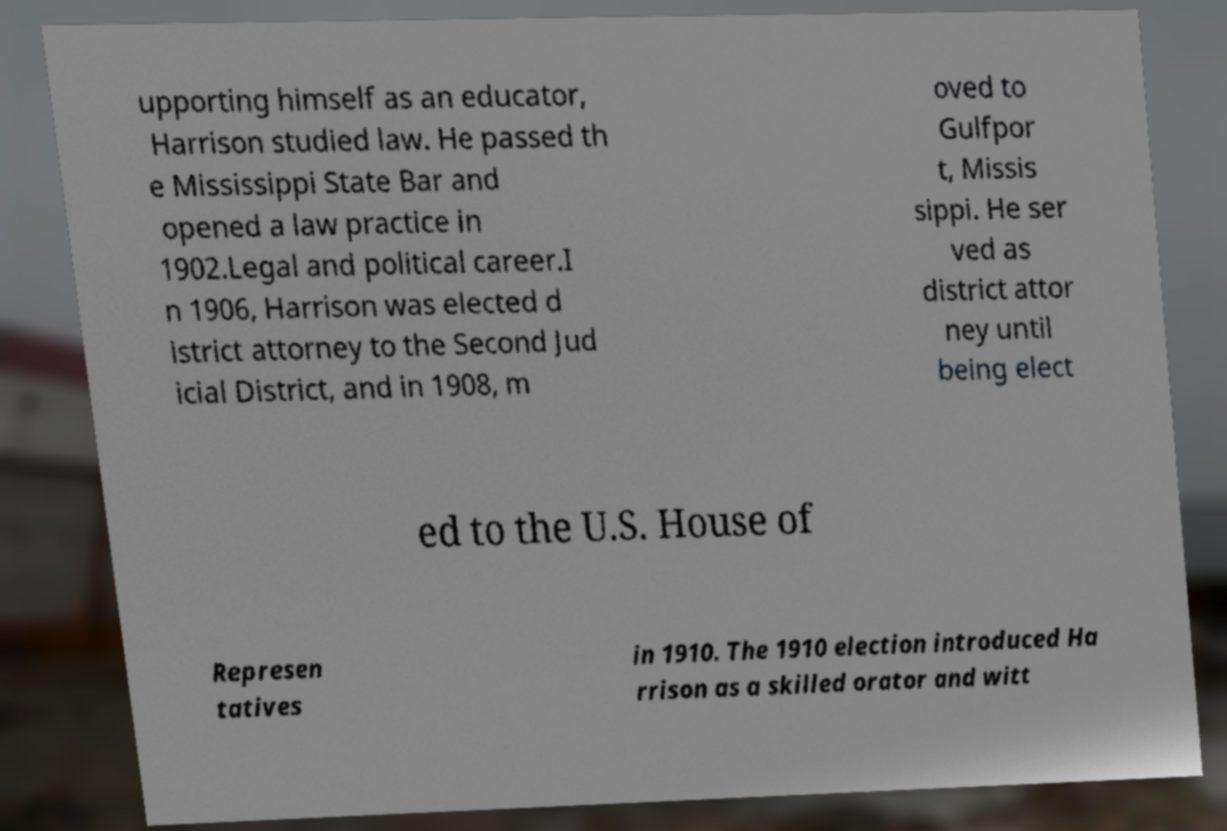Can you accurately transcribe the text from the provided image for me? upporting himself as an educator, Harrison studied law. He passed th e Mississippi State Bar and opened a law practice in 1902.Legal and political career.I n 1906, Harrison was elected d istrict attorney to the Second Jud icial District, and in 1908, m oved to Gulfpor t, Missis sippi. He ser ved as district attor ney until being elect ed to the U.S. House of Represen tatives in 1910. The 1910 election introduced Ha rrison as a skilled orator and witt 